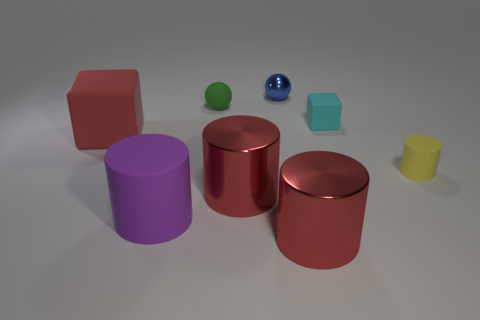What do the objects in the image remind you of? The collection of objects could be reminiscent of a playful, educational set designed to help children learn about shapes and colors. The variety in forms also suggests an abstract art arrangement that one might find in a modern art exhibit. 